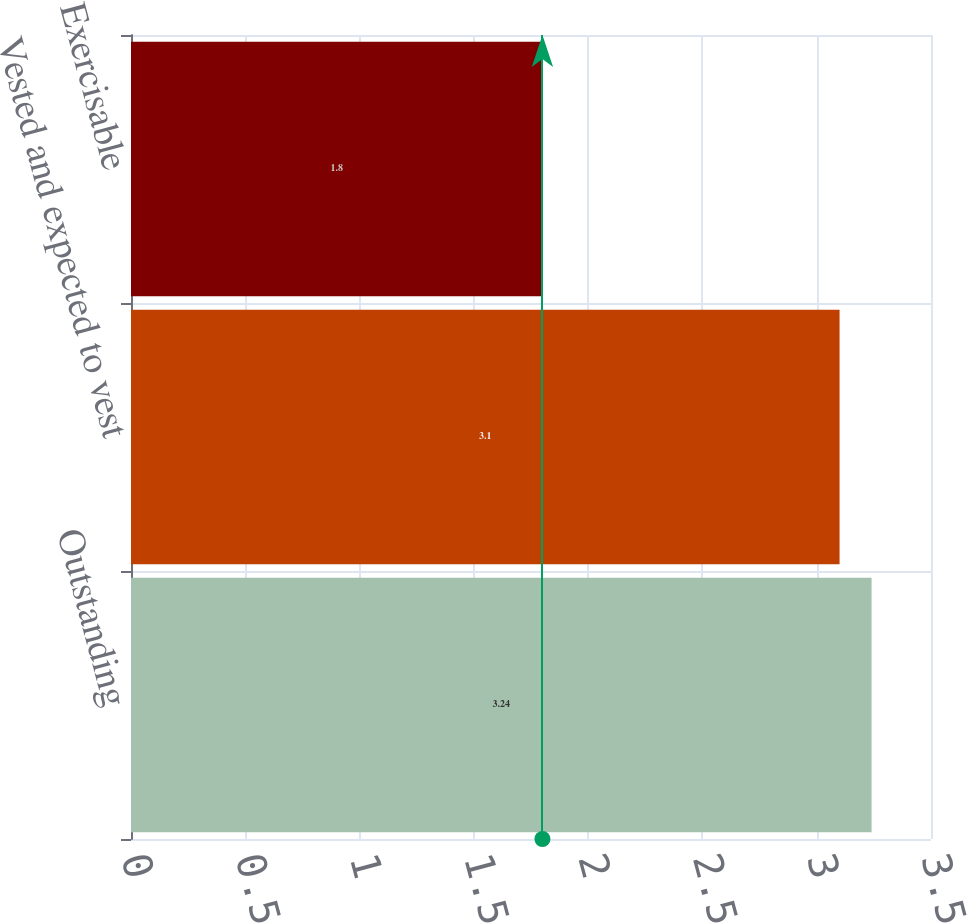<chart> <loc_0><loc_0><loc_500><loc_500><bar_chart><fcel>Outstanding<fcel>Vested and expected to vest<fcel>Exercisable<nl><fcel>3.24<fcel>3.1<fcel>1.8<nl></chart> 